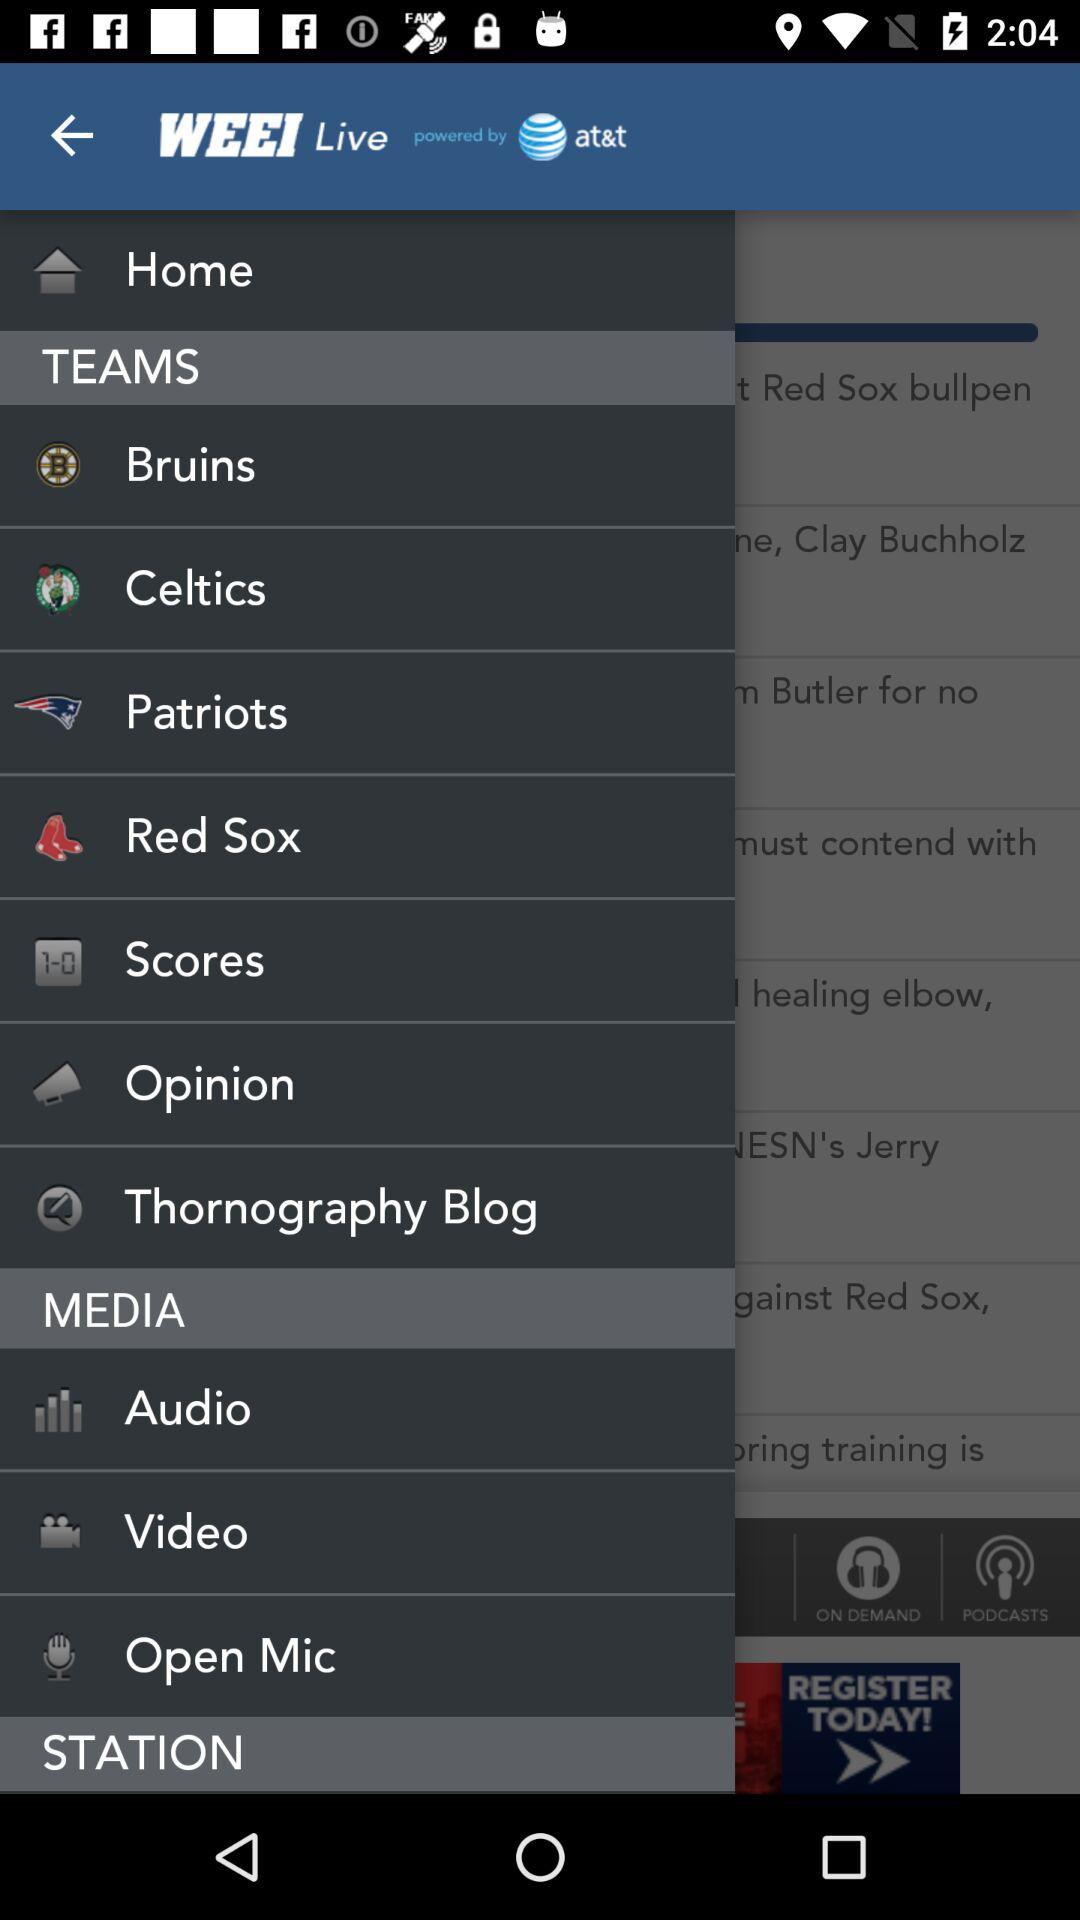What is the app name? The app name is "WEEI Live". 